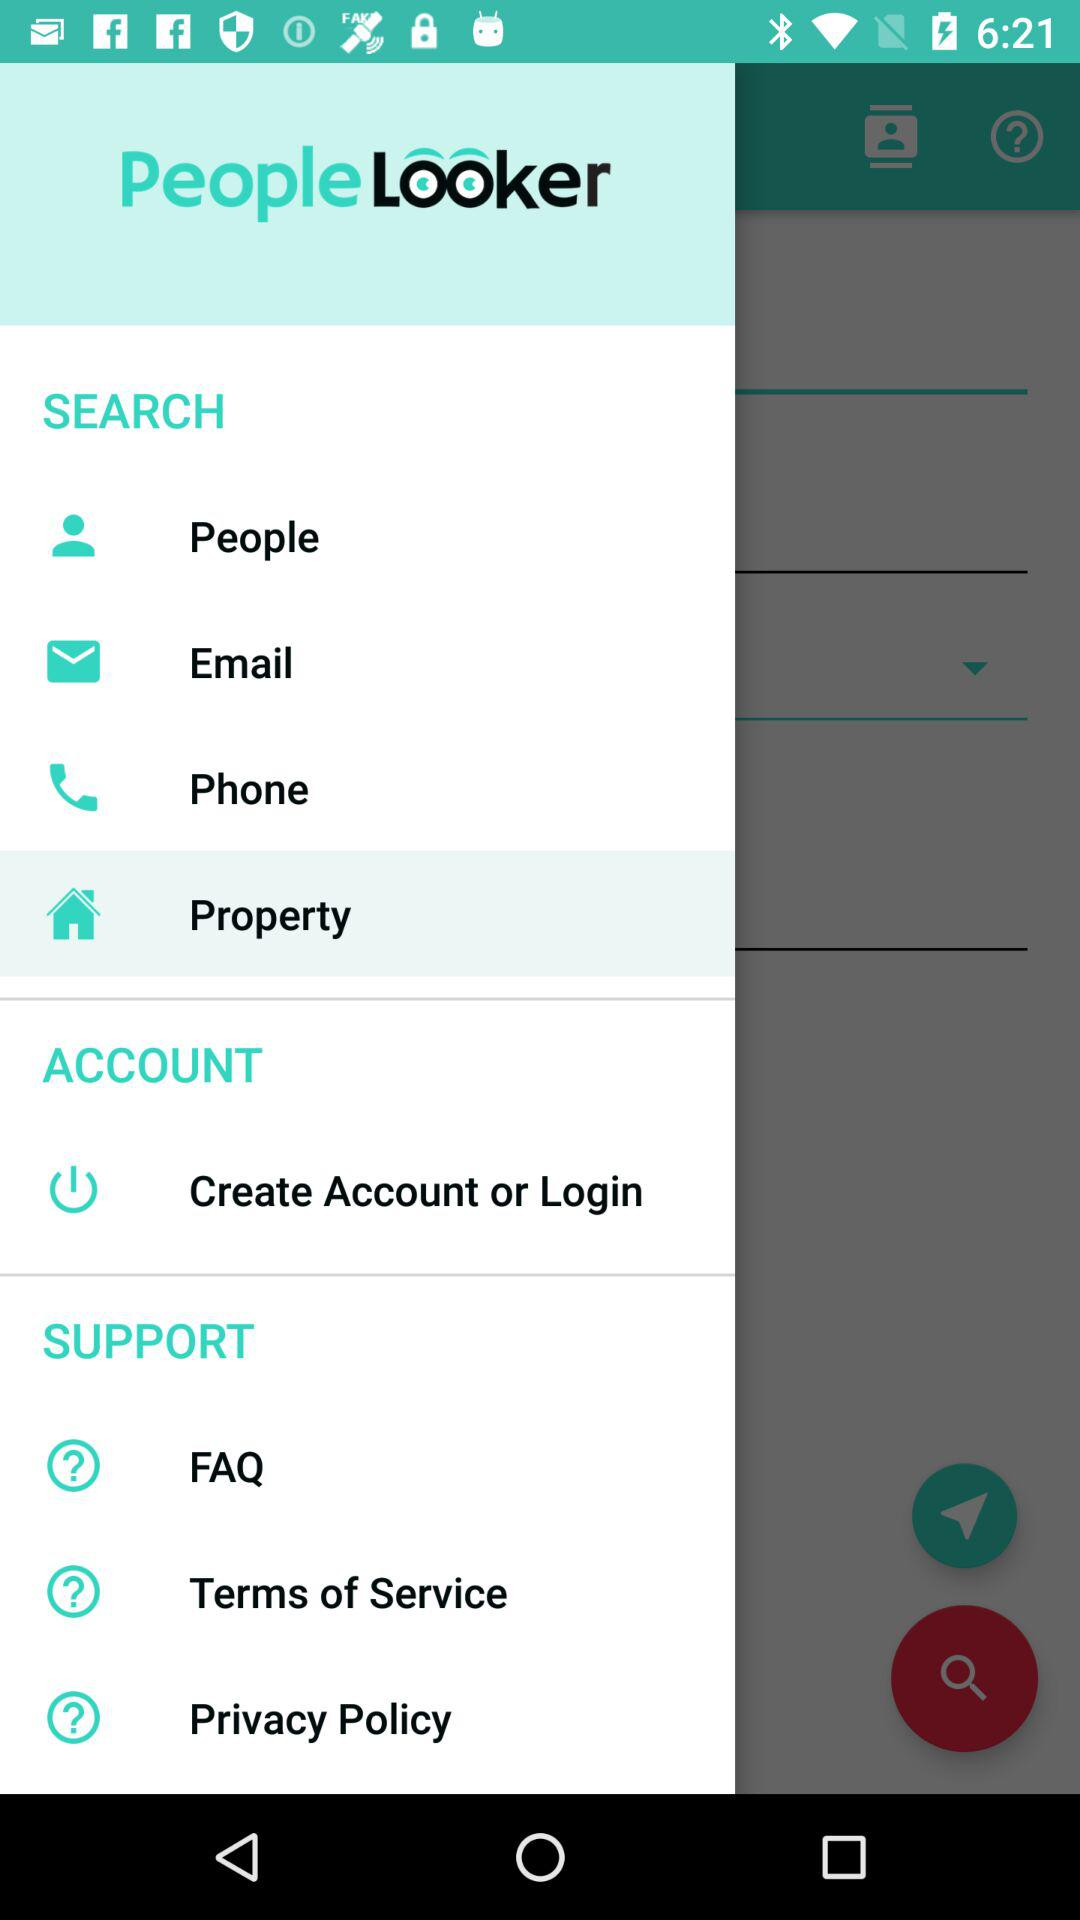What is the name of the application? The name of the application is "People Looker". 